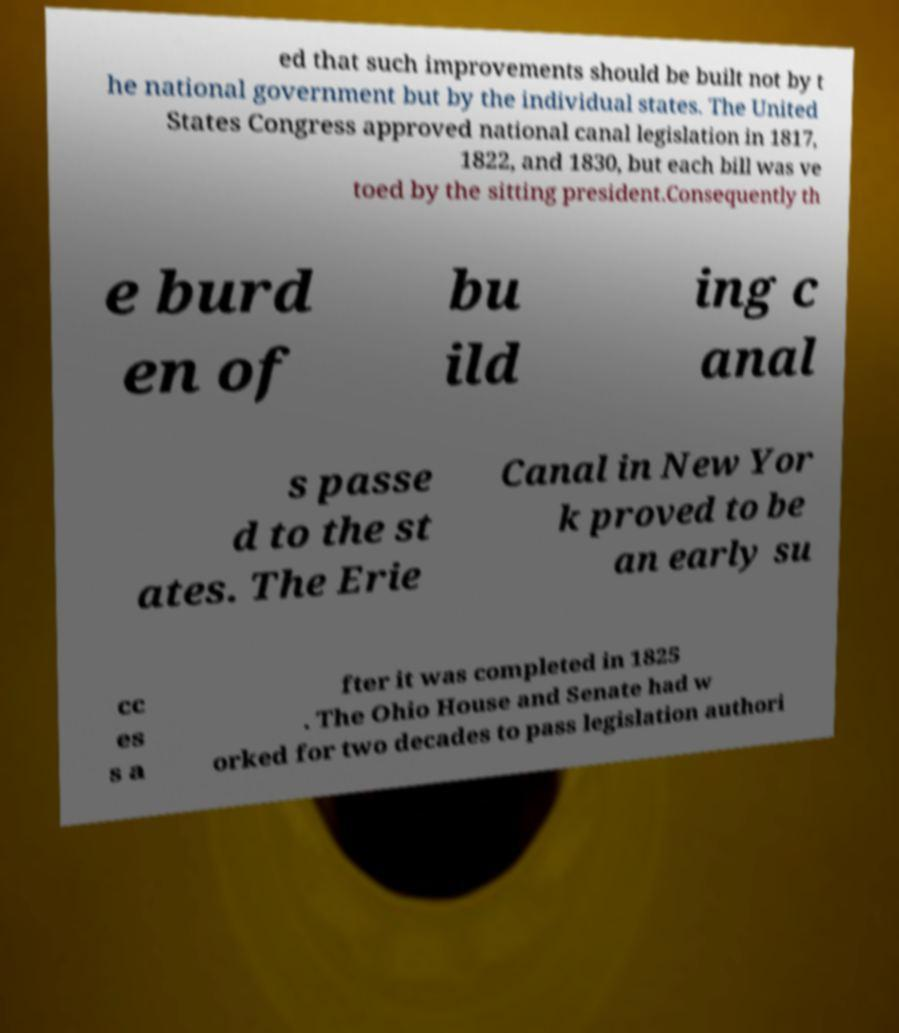For documentation purposes, I need the text within this image transcribed. Could you provide that? ed that such improvements should be built not by t he national government but by the individual states. The United States Congress approved national canal legislation in 1817, 1822, and 1830, but each bill was ve toed by the sitting president.Consequently th e burd en of bu ild ing c anal s passe d to the st ates. The Erie Canal in New Yor k proved to be an early su cc es s a fter it was completed in 1825 . The Ohio House and Senate had w orked for two decades to pass legislation authori 